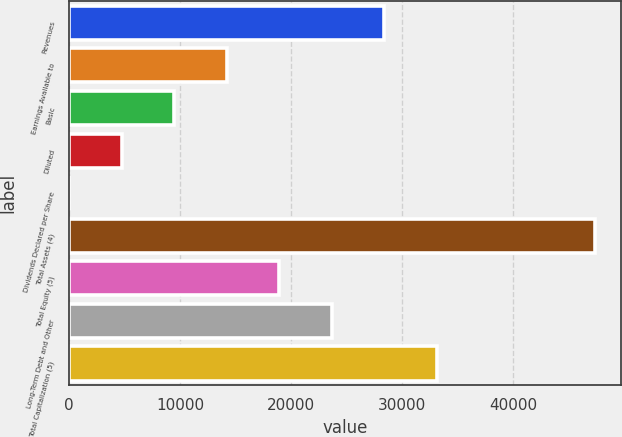<chart> <loc_0><loc_0><loc_500><loc_500><bar_chart><fcel>Revenues<fcel>Earnings Available to<fcel>Basic<fcel>Diluted<fcel>Dividends Declared per Share<fcel>Total Assets (4)<fcel>Total Equity (5)<fcel>Long-Term Debt and Other<fcel>Total Capitalization (5)<nl><fcel>28396.5<fcel>14199.3<fcel>9466.96<fcel>4734.58<fcel>2.2<fcel>47326<fcel>18931.7<fcel>23664.1<fcel>33128.9<nl></chart> 